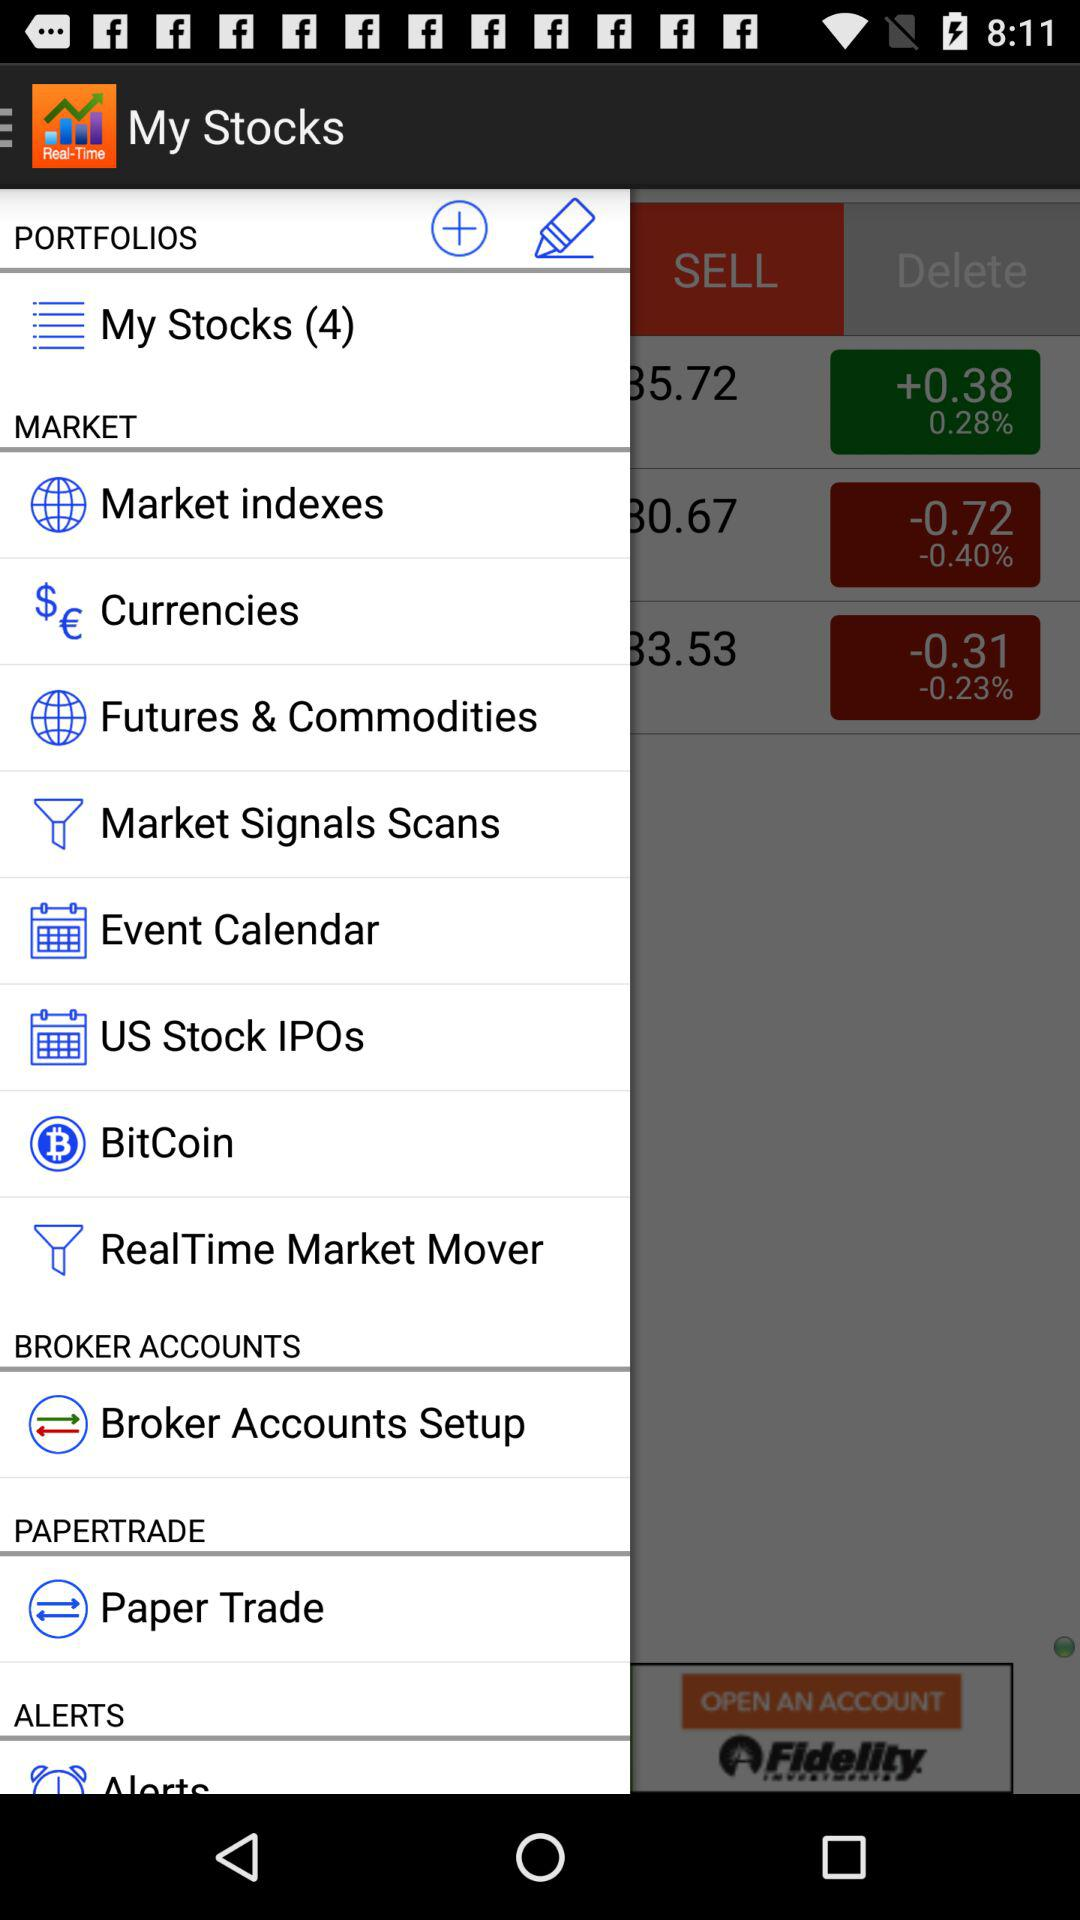What is the application name? The name of the application is "My Stocks". 